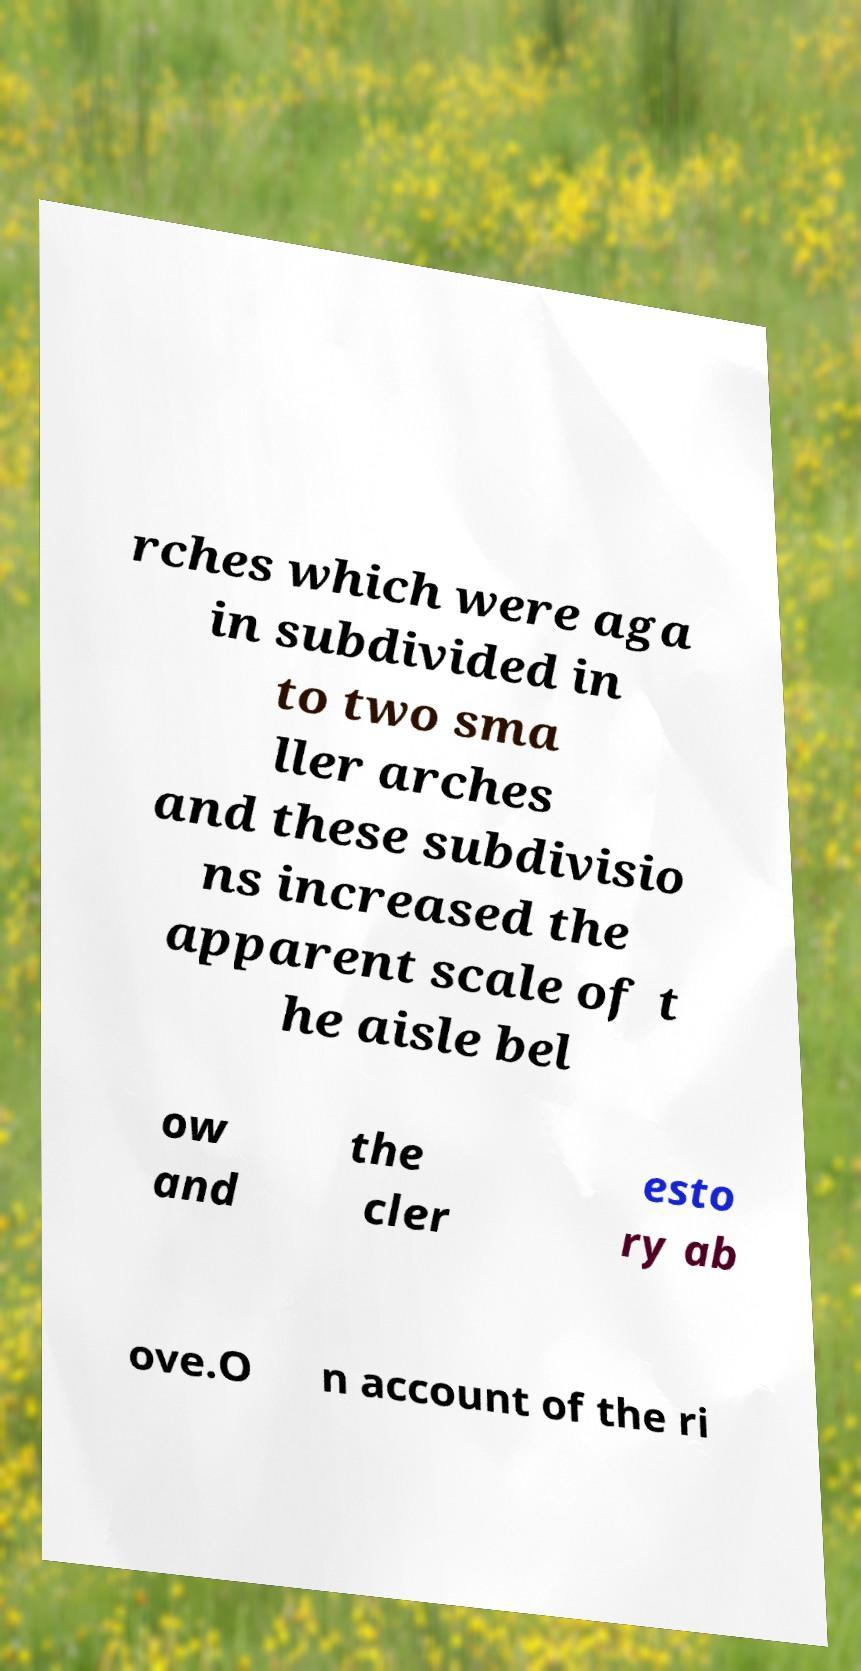For documentation purposes, I need the text within this image transcribed. Could you provide that? rches which were aga in subdivided in to two sma ller arches and these subdivisio ns increased the apparent scale of t he aisle bel ow and the cler esto ry ab ove.O n account of the ri 